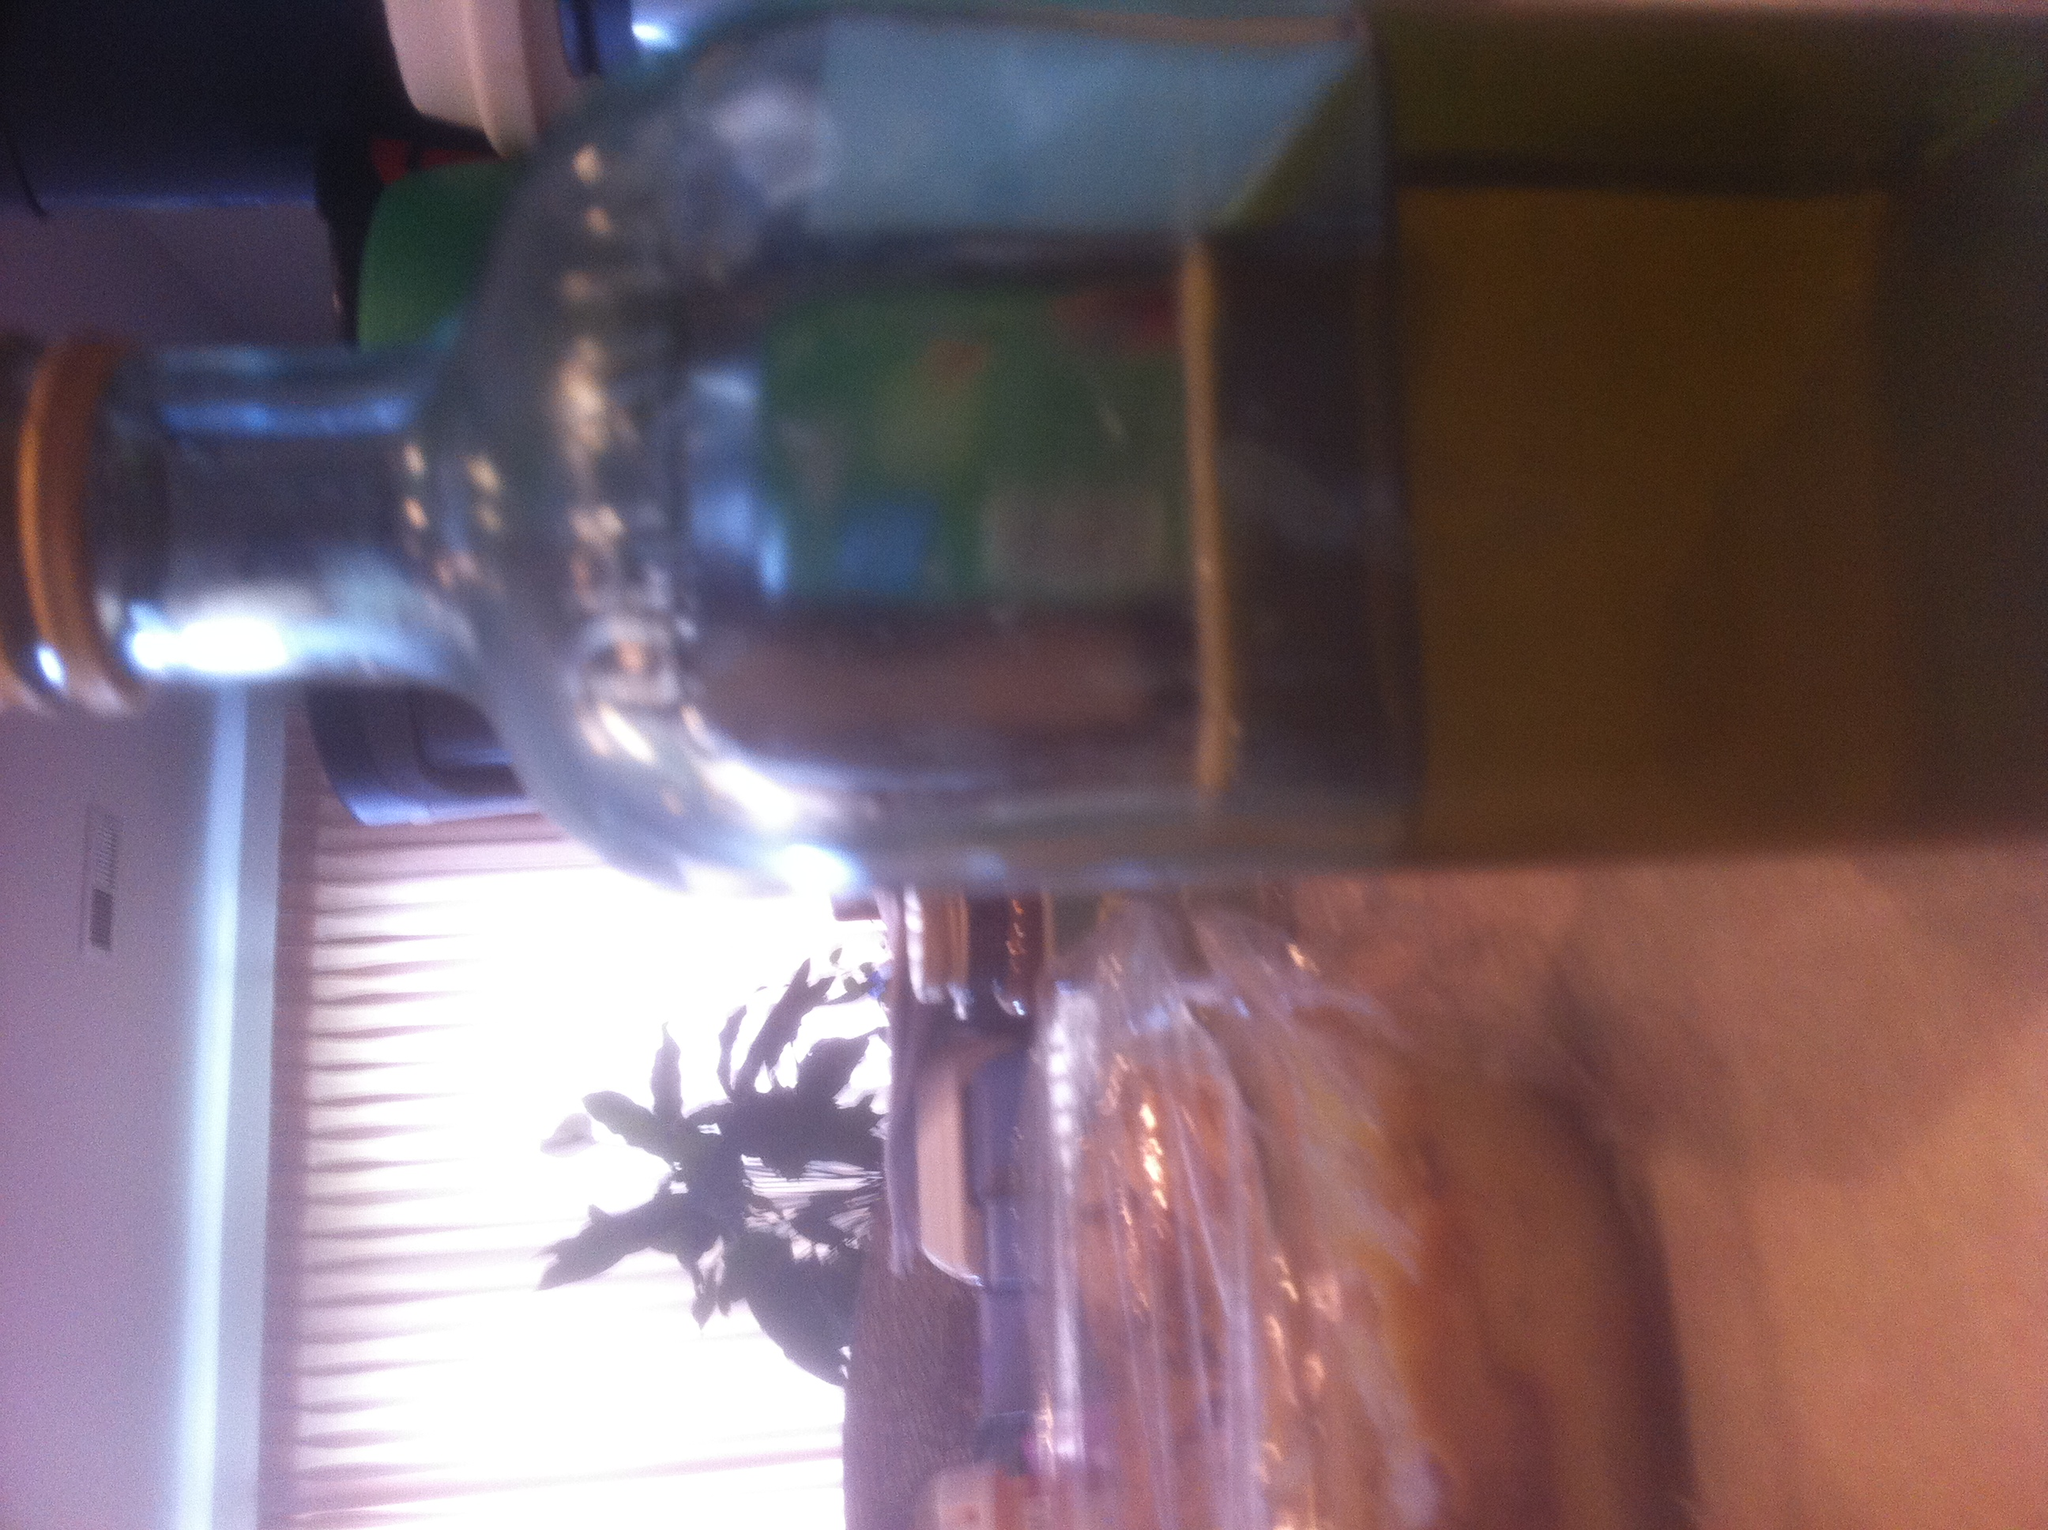Imagine this bottle was found in an ancient archaeological dig. How might historians interpret its use and significance? Finding this bottle in an archaeological dig could reveal fascinating insights into past civilizations. Historians might posit that the bottle was used for storing precious liquids like oils, perfumes, or medicinal concoctions. They would study the bottle's design, material, and any residues to understand its contents and use. Such bottles could indicate trade practices, daily life, and even cultural rituals. They might also be linked to certain historical periods or regions, providing a tangible connection to our ancestors' ways of life. 